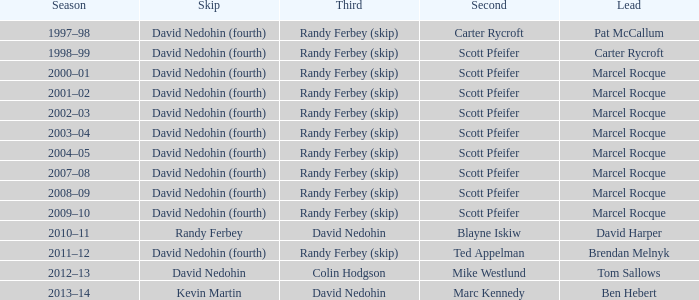Can you parse all the data within this table? {'header': ['Season', 'Skip', 'Third', 'Second', 'Lead'], 'rows': [['1997–98', 'David Nedohin (fourth)', 'Randy Ferbey (skip)', 'Carter Rycroft', 'Pat McCallum'], ['1998–99', 'David Nedohin (fourth)', 'Randy Ferbey (skip)', 'Scott Pfeifer', 'Carter Rycroft'], ['2000–01', 'David Nedohin (fourth)', 'Randy Ferbey (skip)', 'Scott Pfeifer', 'Marcel Rocque'], ['2001–02', 'David Nedohin (fourth)', 'Randy Ferbey (skip)', 'Scott Pfeifer', 'Marcel Rocque'], ['2002–03', 'David Nedohin (fourth)', 'Randy Ferbey (skip)', 'Scott Pfeifer', 'Marcel Rocque'], ['2003–04', 'David Nedohin (fourth)', 'Randy Ferbey (skip)', 'Scott Pfeifer', 'Marcel Rocque'], ['2004–05', 'David Nedohin (fourth)', 'Randy Ferbey (skip)', 'Scott Pfeifer', 'Marcel Rocque'], ['2007–08', 'David Nedohin (fourth)', 'Randy Ferbey (skip)', 'Scott Pfeifer', 'Marcel Rocque'], ['2008–09', 'David Nedohin (fourth)', 'Randy Ferbey (skip)', 'Scott Pfeifer', 'Marcel Rocque'], ['2009–10', 'David Nedohin (fourth)', 'Randy Ferbey (skip)', 'Scott Pfeifer', 'Marcel Rocque'], ['2010–11', 'Randy Ferbey', 'David Nedohin', 'Blayne Iskiw', 'David Harper'], ['2011–12', 'David Nedohin (fourth)', 'Randy Ferbey (skip)', 'Ted Appelman', 'Brendan Melnyk'], ['2012–13', 'David Nedohin', 'Colin Hodgson', 'Mike Westlund', 'Tom Sallows'], ['2013–14', 'Kevin Martin', 'David Nedohin', 'Marc Kennedy', 'Ben Hebert']]} Which Lead has a Third of randy ferbey (skip), a Second of scott pfeifer, and a Season of 2009–10? Marcel Rocque. 